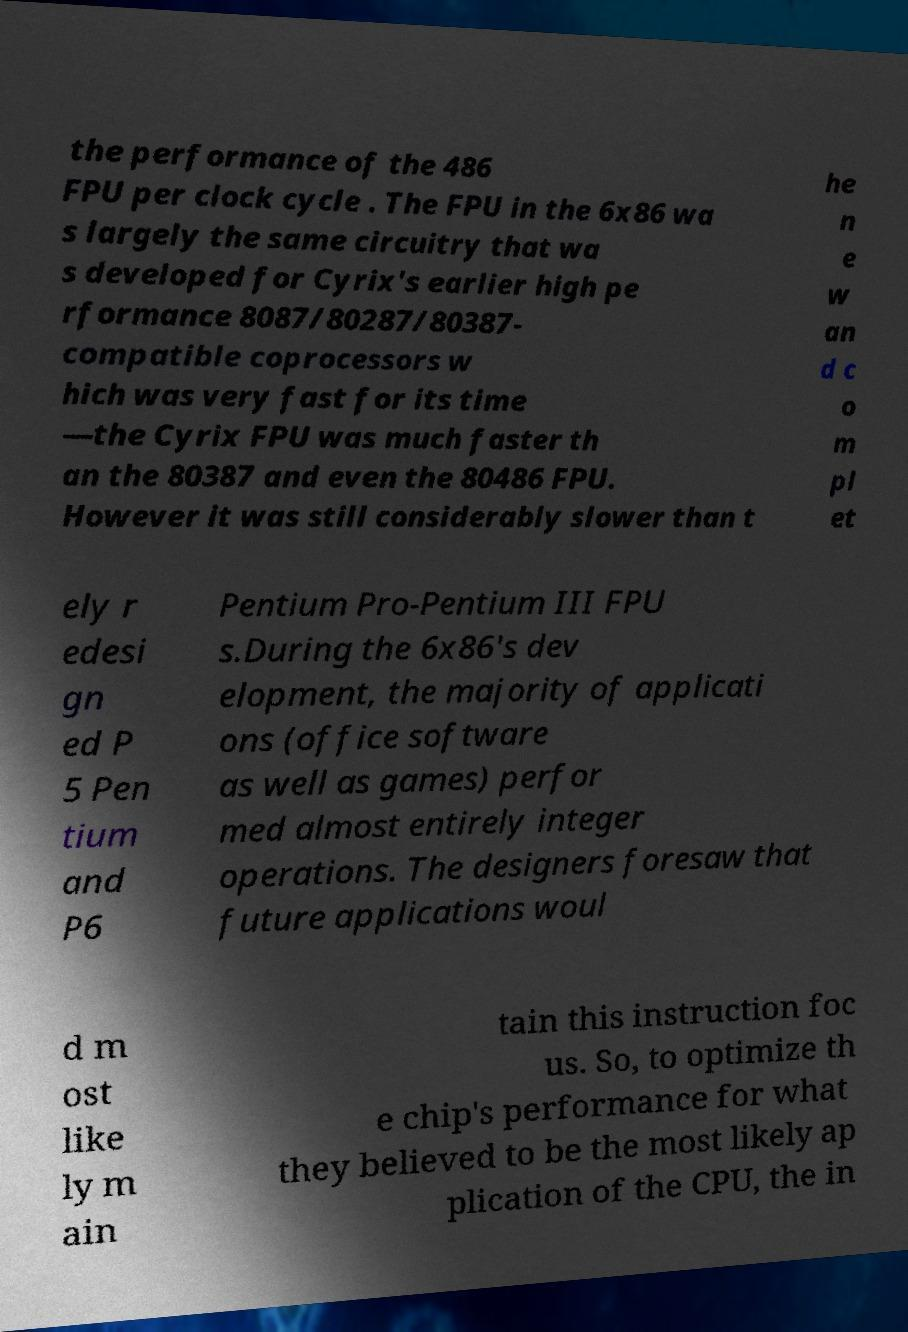What messages or text are displayed in this image? I need them in a readable, typed format. the performance of the 486 FPU per clock cycle . The FPU in the 6x86 wa s largely the same circuitry that wa s developed for Cyrix's earlier high pe rformance 8087/80287/80387- compatible coprocessors w hich was very fast for its time —the Cyrix FPU was much faster th an the 80387 and even the 80486 FPU. However it was still considerably slower than t he n e w an d c o m pl et ely r edesi gn ed P 5 Pen tium and P6 Pentium Pro-Pentium III FPU s.During the 6x86's dev elopment, the majority of applicati ons (office software as well as games) perfor med almost entirely integer operations. The designers foresaw that future applications woul d m ost like ly m ain tain this instruction foc us. So, to optimize th e chip's performance for what they believed to be the most likely ap plication of the CPU, the in 